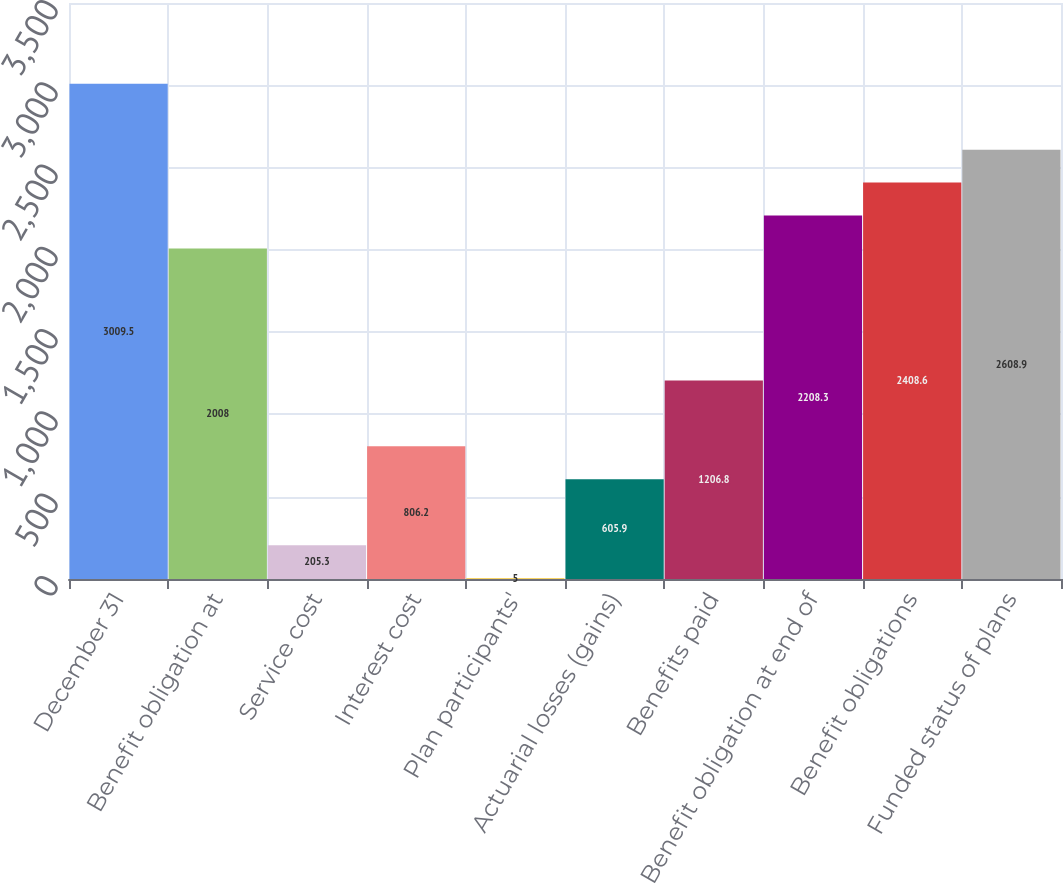Convert chart. <chart><loc_0><loc_0><loc_500><loc_500><bar_chart><fcel>December 31<fcel>Benefit obligation at<fcel>Service cost<fcel>Interest cost<fcel>Plan participants'<fcel>Actuarial losses (gains)<fcel>Benefits paid<fcel>Benefit obligation at end of<fcel>Benefit obligations<fcel>Funded status of plans<nl><fcel>3009.5<fcel>2008<fcel>205.3<fcel>806.2<fcel>5<fcel>605.9<fcel>1206.8<fcel>2208.3<fcel>2408.6<fcel>2608.9<nl></chart> 